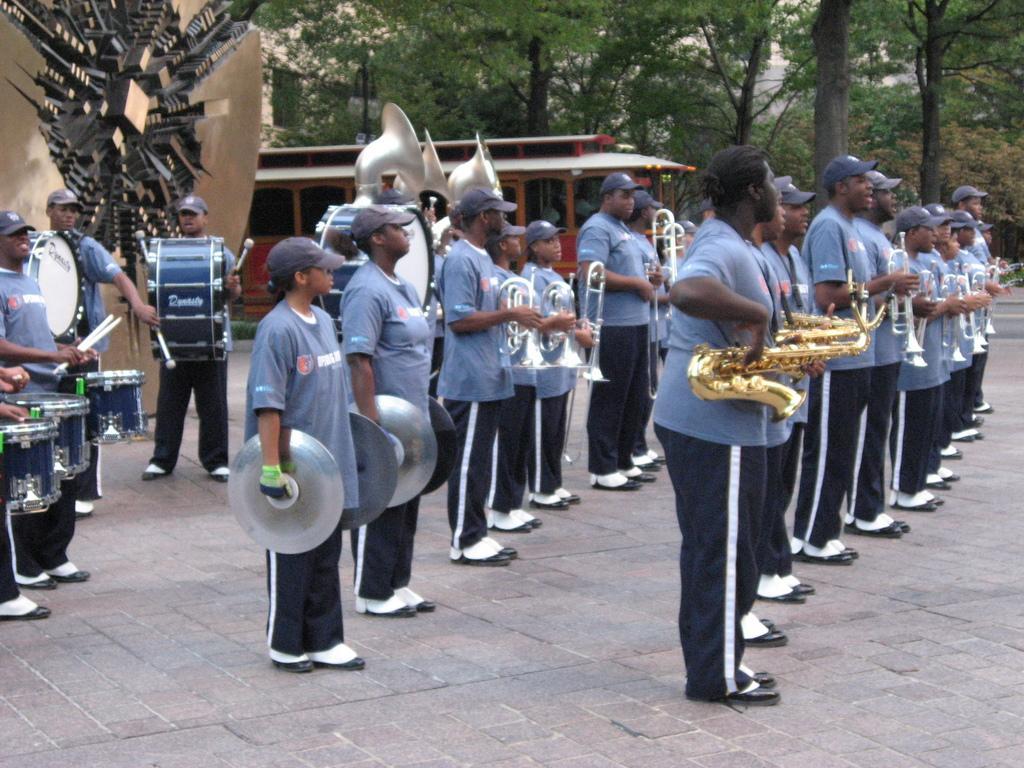Can you describe this image briefly? On the background we can see trees and a house. This is an arch. We can see all the persons standing and playing musical instruments. 